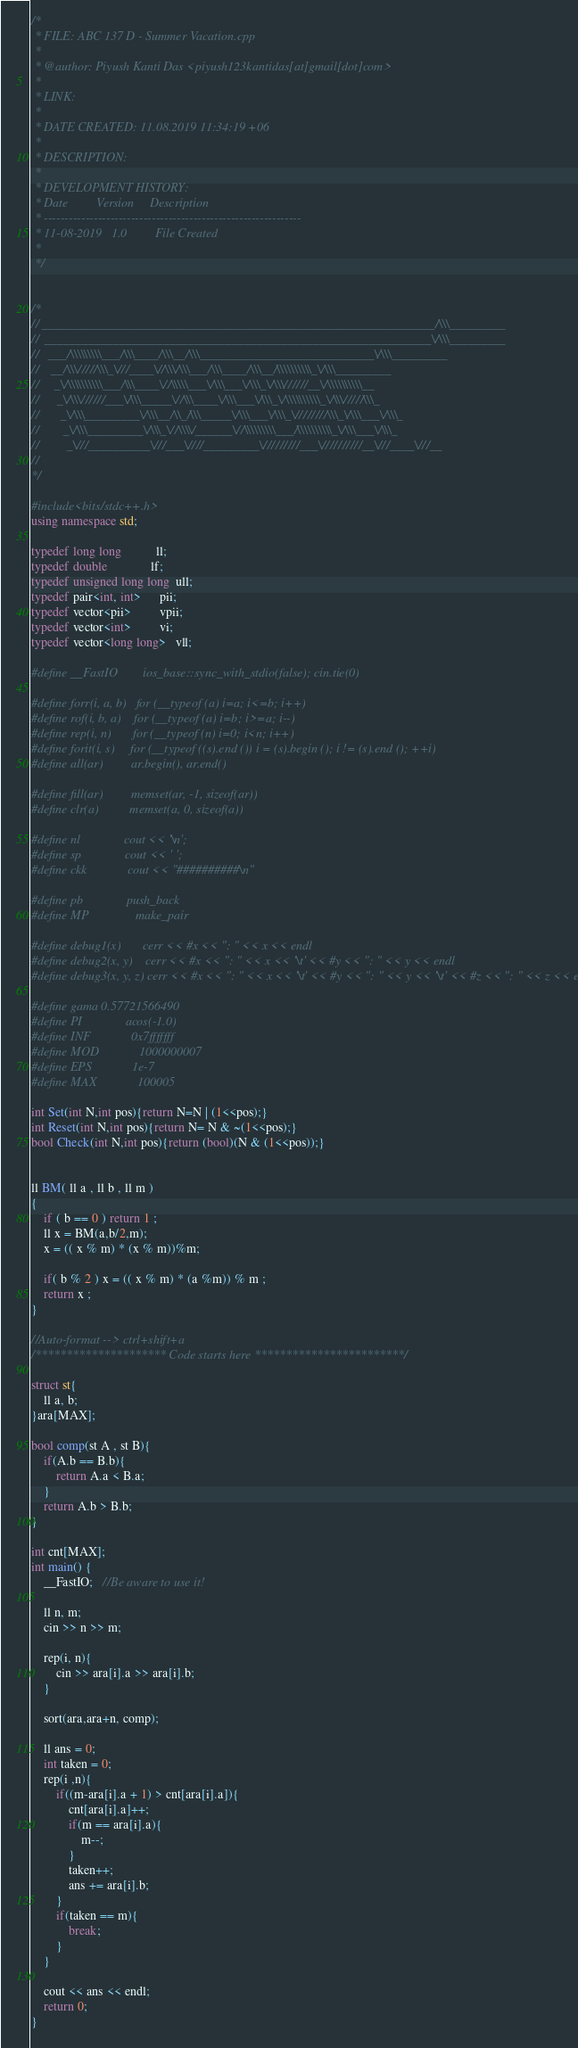Convert code to text. <code><loc_0><loc_0><loc_500><loc_500><_C++_>/*
 * FILE: ABC 137 D - Summer Vacation.cpp
 *
 * @author: Piyush Kanti Das <piyush123kantidas[at]gmail[dot]com>
 *
 * LINK:
 *
 * DATE CREATED: 11.08.2019 11:34:19 +06
 *
 * DESCRIPTION:
 *
 * DEVELOPMENT HISTORY:
 * Date         Version     Description
 * --------------------------------------------------------------
 * 11-08-2019	1.0         File Created
 *
 */


/*
// _______________________________________________________________/\\\_________
//  ______________________________________________________________\/\\\_________
//   ___/\\\\\\\\\___/\\\____/\\\__/\\\____________________________\/\\\_________
//    __/\\\/////\\\_\///____\//\\\/\\\___/\\\____/\\\__/\\\\\\\\\\_\/\\\_________
//     _\/\\\\\\\\\\___/\\\____\//\\\\\___\/\\\___\/\\\_\/\\\//////__\/\\\\\\\\\\__
//      _\/\\\//////___\/\\\_____\//\\\____\/\\\___\/\\\_\/\\\\\\\\\\_\/\\\/////\\\_
//       _\/\\\_________\/\\\__/\\_/\\\_____\/\\\___\/\\\_\////////\\\_\/\\\___\/\\\_
//        _\/\\\_________\/\\\_\//\\\\/______\//\\\\\\\\\___/\\\\\\\\\\_\/\\\___\/\\\_
//         _\///__________\///___\////_________\/////////___\//////////__\///____\///__
//
*/

#include<bits/stdc++.h>
using namespace std;

typedef long long           ll;
typedef double              lf;
typedef unsigned long long  ull;
typedef pair<int, int>      pii;
typedef vector<pii>         vpii;
typedef vector<int>         vi;
typedef vector<long long>   vll;

#define __FastIO        ios_base::sync_with_stdio(false); cin.tie(0)

#define forr(i, a, b)   for (__typeof (a) i=a; i<=b; i++)
#define rof(i, b, a)    for (__typeof (a) i=b; i>=a; i--)
#define rep(i, n)       for (__typeof (n) i=0; i<n; i++)
#define forit(i, s)     for (__typeof ((s).end ()) i = (s).begin (); i != (s).end (); ++i)
#define all(ar)         ar.begin(), ar.end()

#define fill(ar)   		memset(ar, -1, sizeof(ar))
#define clr(a)          memset(a, 0, sizeof(a))

#define nl              cout << '\n';
#define sp              cout << ' ';
#define ckk             cout << "##########\n"

#define pb              push_back
#define MP 				make_pair

#define debug1(x)       cerr << #x << ": " << x << endl
#define debug2(x, y)    cerr << #x << ": " << x << '\t' << #y << ": " << y << endl
#define debug3(x, y, z) cerr << #x << ": " << x << '\t' << #y << ": " << y << '\t' << #z << ": " << z << endl

#define gama 0.57721566490
#define PI              acos(-1.0)
#define INF             0x7fffffff
#define MOD             1000000007
#define EPS             1e-7
#define MAX             100005

int Set(int N,int pos){return N=N | (1<<pos);}
int Reset(int N,int pos){return N= N & ~(1<<pos);}
bool Check(int N,int pos){return (bool)(N & (1<<pos));}


ll BM( ll a , ll b , ll m )
{
    if ( b == 0 ) return 1 ;
    ll x = BM(a,b/2,m);
    x = (( x % m) * (x % m))%m;
    
    if( b % 2 ) x = (( x % m) * (a %m)) % m ;
    return x ;
}

//Auto-format --> ctrl+shift+a
/********************* Code starts here ************************/

struct st{
	ll a, b;
}ara[MAX];

bool comp(st A , st B){
	if(A.b == B.b){
		return A.a < B.a;
	}
	return A.b > B.b;
}

int cnt[MAX];
int main() {
    __FastIO;   //Be aware to use it!
	
	ll n, m;
	cin >> n >> m;
	
	rep(i, n){
		cin >> ara[i].a >> ara[i].b;
	}
	
	sort(ara,ara+n, comp);
	
	ll ans = 0;
	int taken = 0;
	rep(i ,n){
		if((m-ara[i].a + 1) > cnt[ara[i].a]){
			cnt[ara[i].a]++;
			if(m == ara[i].a){
				m--;
			}
			taken++;
			ans += ara[i].b;
		}
		if(taken == m){
			break;
		}
	}
	
	cout << ans << endl;
    return 0;
}
</code> 